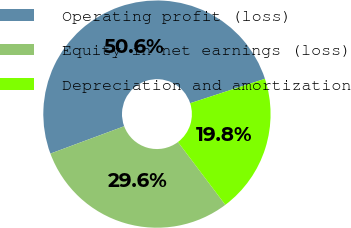<chart> <loc_0><loc_0><loc_500><loc_500><pie_chart><fcel>Operating profit (loss)<fcel>Equity in net earnings (loss)<fcel>Depreciation and amortization<nl><fcel>50.62%<fcel>29.63%<fcel>19.75%<nl></chart> 